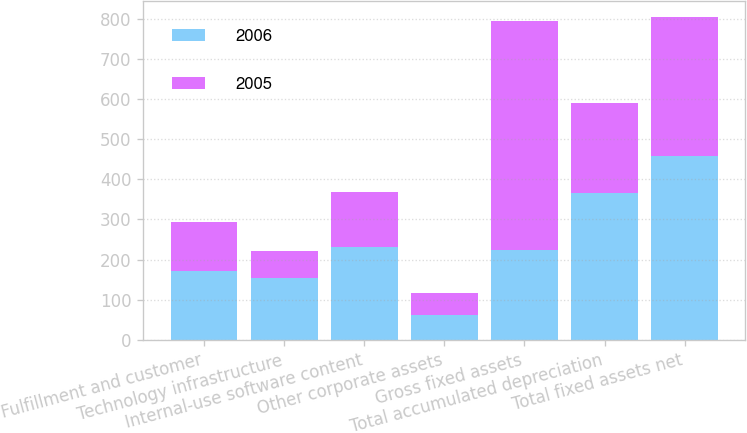Convert chart to OTSL. <chart><loc_0><loc_0><loc_500><loc_500><stacked_bar_chart><ecel><fcel>Fulfillment and customer<fcel>Technology infrastructure<fcel>Internal-use software content<fcel>Other corporate assets<fcel>Gross fixed assets<fcel>Total accumulated depreciation<fcel>Total fixed assets net<nl><fcel>2006<fcel>171<fcel>153<fcel>230<fcel>62<fcel>223<fcel>367<fcel>457<nl><fcel>2005<fcel>123<fcel>69<fcel>138<fcel>55<fcel>571<fcel>223<fcel>348<nl></chart> 